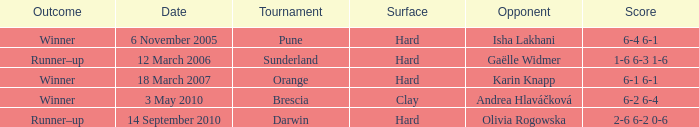What was the score of the tournament against Isha Lakhani? 6-4 6-1. 